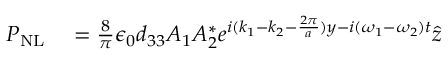Convert formula to latex. <formula><loc_0><loc_0><loc_500><loc_500>\begin{array} { r l } { P _ { N L } } & = \frac { 8 } { \pi } \epsilon _ { 0 } d _ { 3 3 } A _ { 1 } A _ { 2 } ^ { * } e ^ { i ( k _ { 1 } - k _ { 2 } - \frac { 2 \pi } { a } ) y - i ( \omega _ { 1 } - \omega _ { 2 } ) t } \hat { z } } \end{array}</formula> 